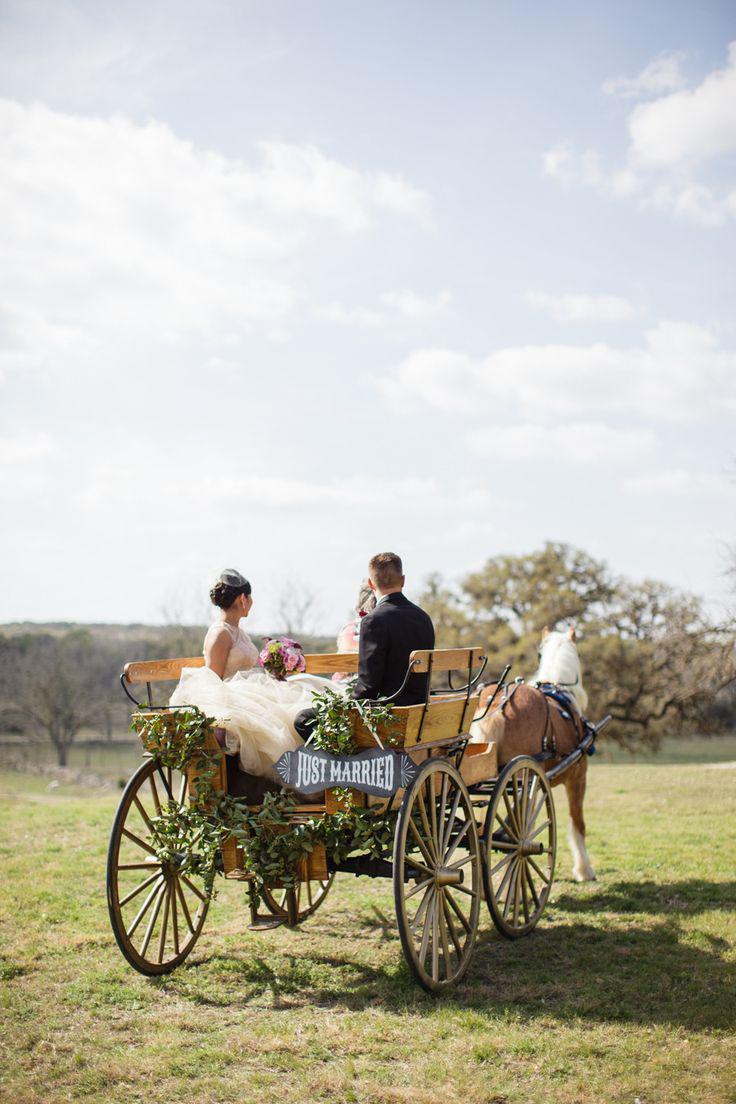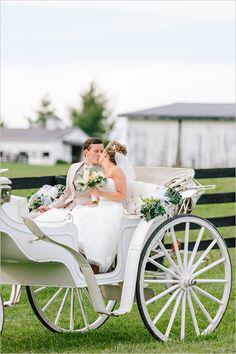The first image is the image on the left, the second image is the image on the right. Assess this claim about the two images: "An image shows at least one member of a wedding party in the back of a four-wheeled carriage heading away from the camera.". Correct or not? Answer yes or no. Yes. The first image is the image on the left, the second image is the image on the right. Assess this claim about the two images: "The wheels on each of the carts are spoked wooden ones .". Correct or not? Answer yes or no. Yes. 